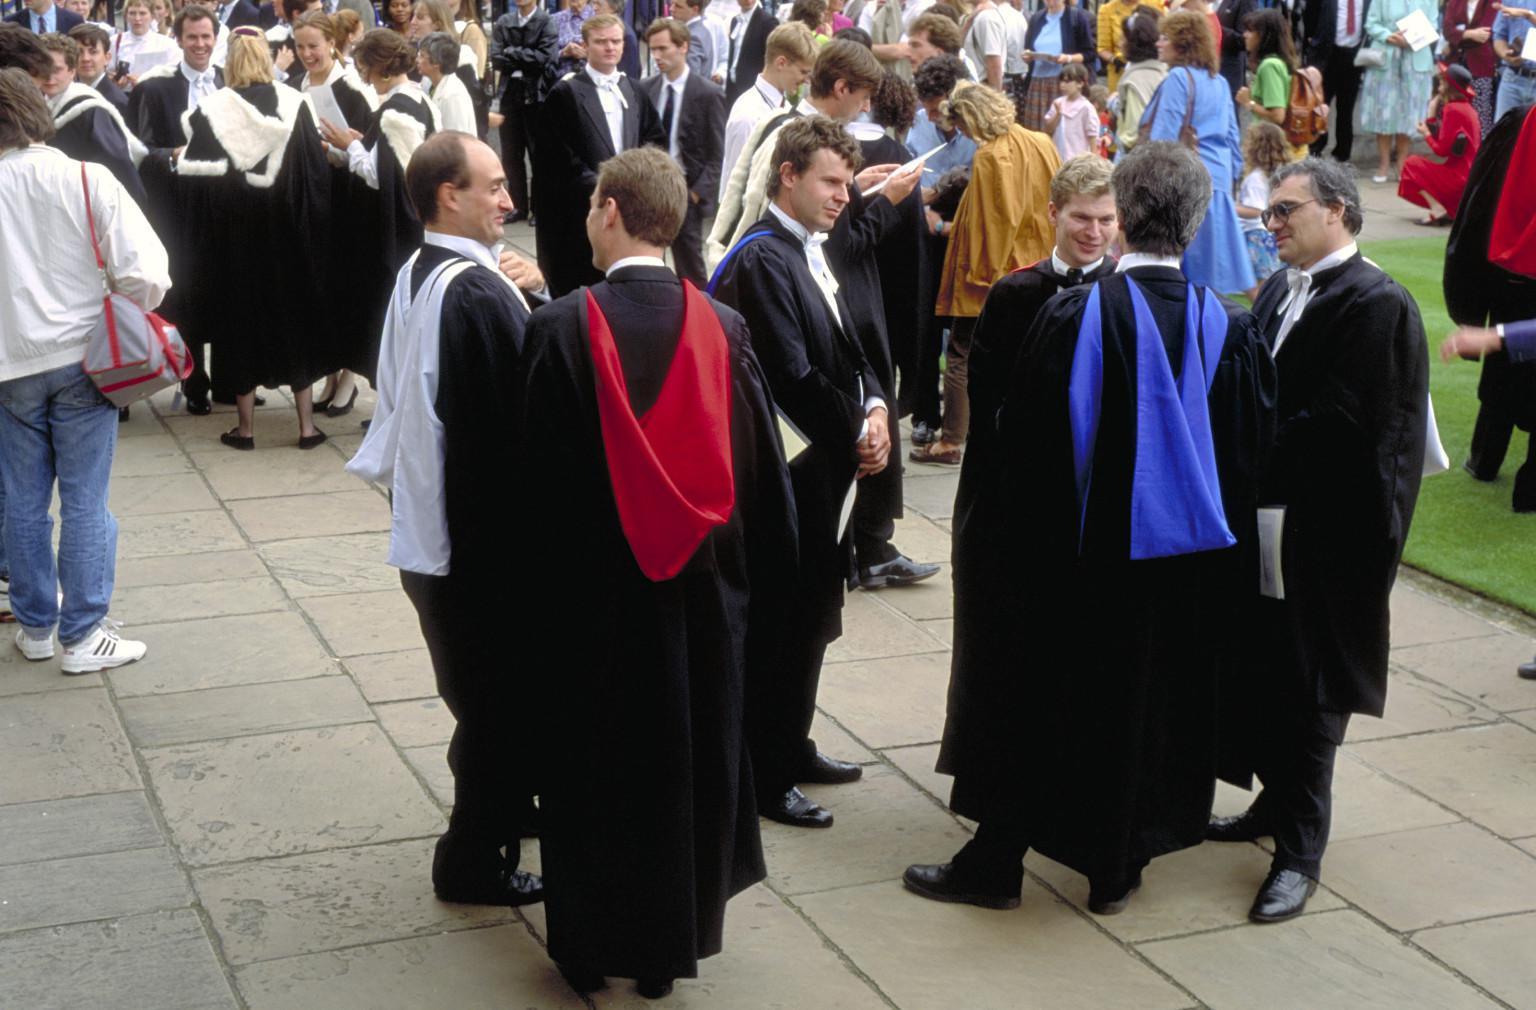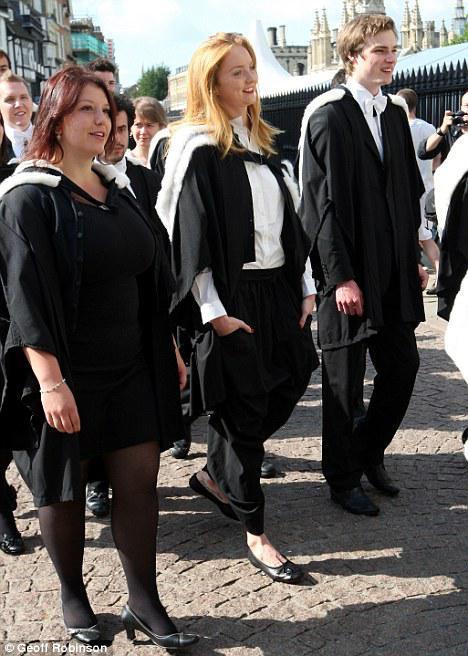The first image is the image on the left, the second image is the image on the right. For the images shown, is this caption "The left image contains no more than two graduation students." true? Answer yes or no. No. The first image is the image on the left, the second image is the image on the right. For the images shown, is this caption "An image contains one front-facing graduate, a young man wearing a white bow around his neck and no cap." true? Answer yes or no. No. 